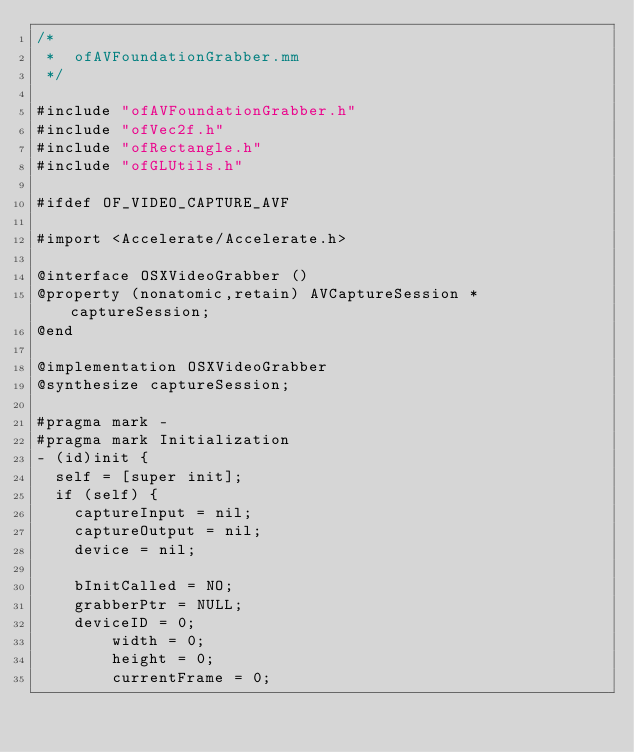Convert code to text. <code><loc_0><loc_0><loc_500><loc_500><_ObjectiveC_>/*
 *  ofAVFoundationGrabber.mm
 */

#include "ofAVFoundationGrabber.h"
#include "ofVec2f.h"
#include "ofRectangle.h"
#include "ofGLUtils.h"

#ifdef OF_VIDEO_CAPTURE_AVF

#import <Accelerate/Accelerate.h>

@interface OSXVideoGrabber ()
@property (nonatomic,retain) AVCaptureSession *captureSession;
@end

@implementation OSXVideoGrabber
@synthesize captureSession;

#pragma mark -
#pragma mark Initialization
- (id)init {
	self = [super init];
	if (self) {
		captureInput = nil;
		captureOutput = nil;
		device = nil;

		bInitCalled = NO;
		grabberPtr = NULL;
		deviceID = 0;
        width = 0;
        height = 0;
        currentFrame = 0;</code> 